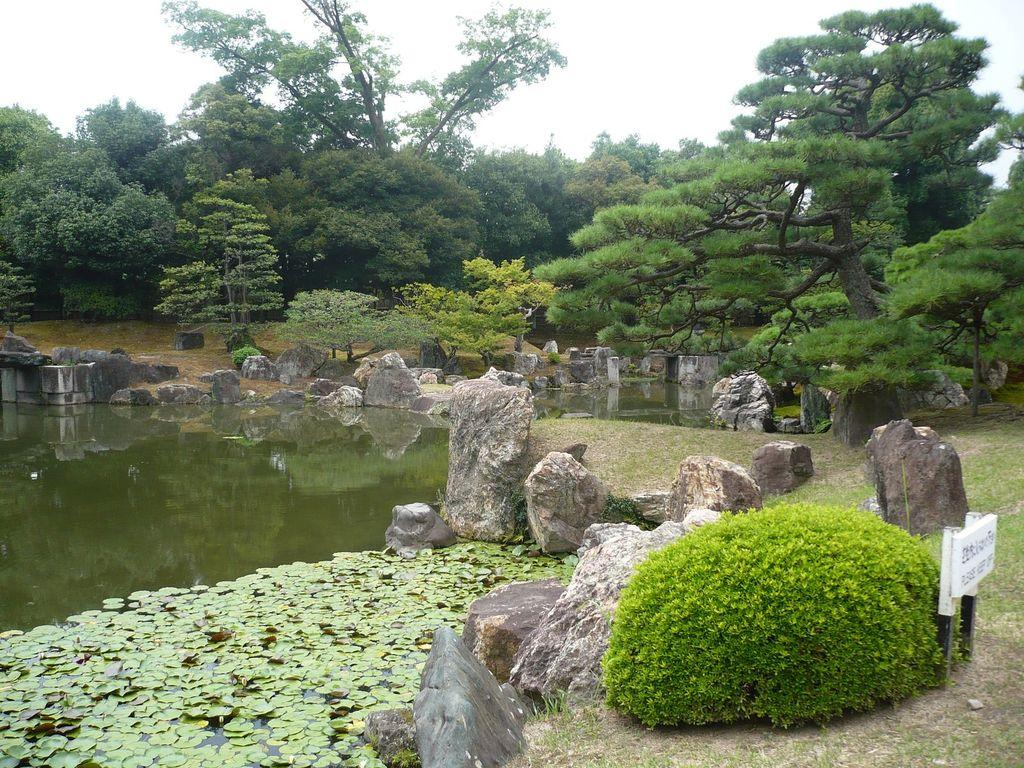What can be seen in the sky in the image? The sky is visible in the image, and there are clouds present. What type of vegetation is visible in the image? Trees, plants, and grass are present in the image. What natural element can be seen in the image? There is water visible in the image. What type of ground surface is present in the image? Stones are present in the image. What man-made object is visible in the image? There is a sign board in the image. Where is the table located in the image? There is no table present in the image. What type of waste can be seen in the image? There is no waste visible in the image. 